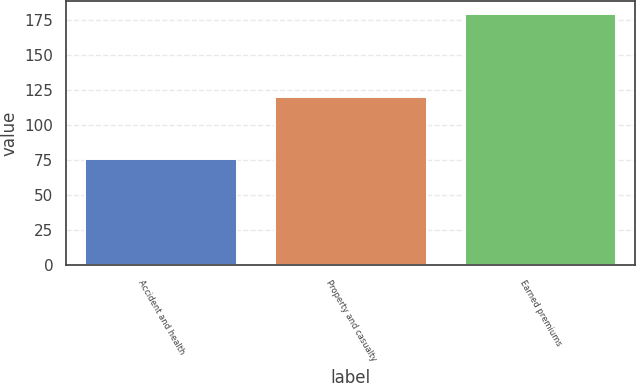Convert chart to OTSL. <chart><loc_0><loc_0><loc_500><loc_500><bar_chart><fcel>Accident and health<fcel>Property and casualty<fcel>Earned premiums<nl><fcel>76<fcel>120<fcel>179<nl></chart> 